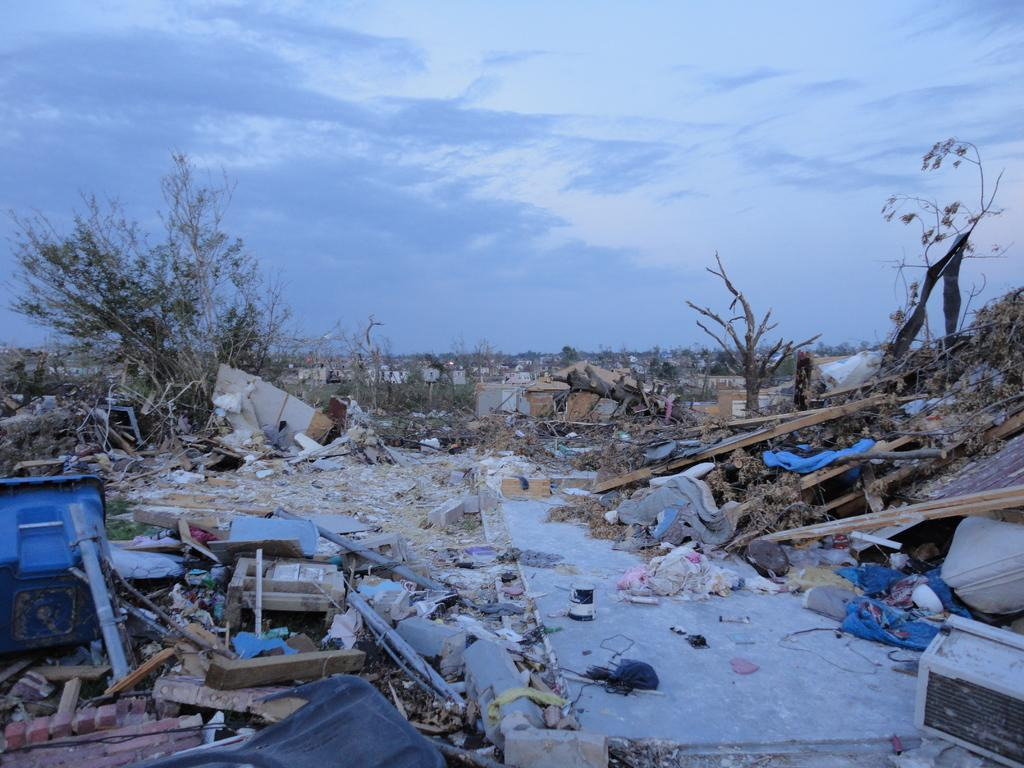What is the condition of the sky in the image? The sky in the image is cloudy. What type of vegetation can be seen in the image? There are many plants in the image. What is present on the ground in the image? There are many objects on the ground in the image. Are there any plants that appear to be dry in the image? Yes, there are dry plants in the image. Can you see any geese running along the waves in the image? There are no geese or waves present in the image. 